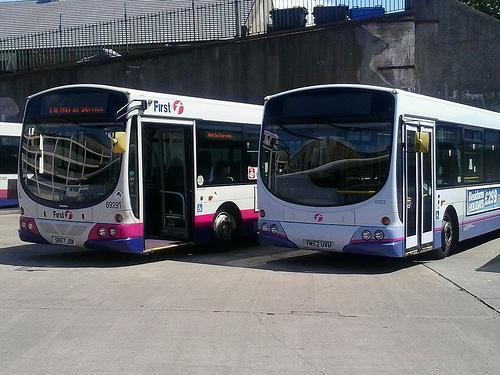How many buses are in the picture?
Give a very brief answer. 3. How many buses are the doors open?
Give a very brief answer. 1. 